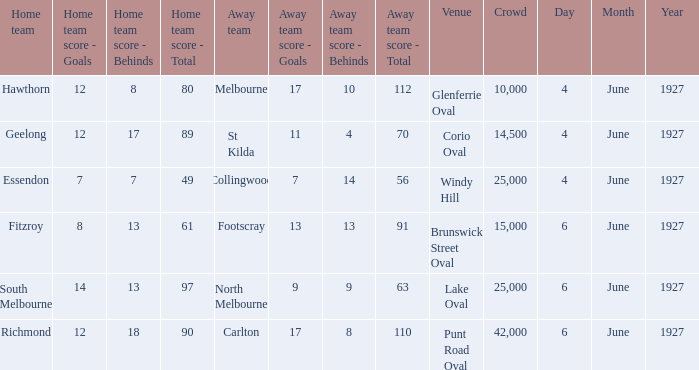Which team was at Corio Oval on 4 June 1927? St Kilda. 